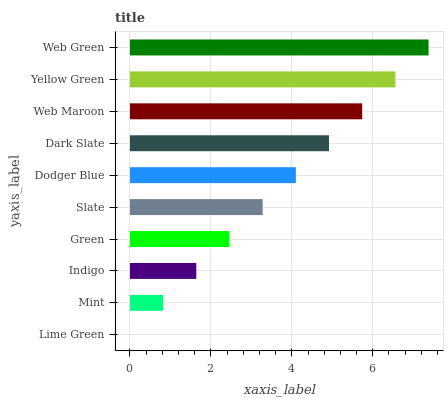Is Lime Green the minimum?
Answer yes or no. Yes. Is Web Green the maximum?
Answer yes or no. Yes. Is Mint the minimum?
Answer yes or no. No. Is Mint the maximum?
Answer yes or no. No. Is Mint greater than Lime Green?
Answer yes or no. Yes. Is Lime Green less than Mint?
Answer yes or no. Yes. Is Lime Green greater than Mint?
Answer yes or no. No. Is Mint less than Lime Green?
Answer yes or no. No. Is Dodger Blue the high median?
Answer yes or no. Yes. Is Slate the low median?
Answer yes or no. Yes. Is Indigo the high median?
Answer yes or no. No. Is Green the low median?
Answer yes or no. No. 